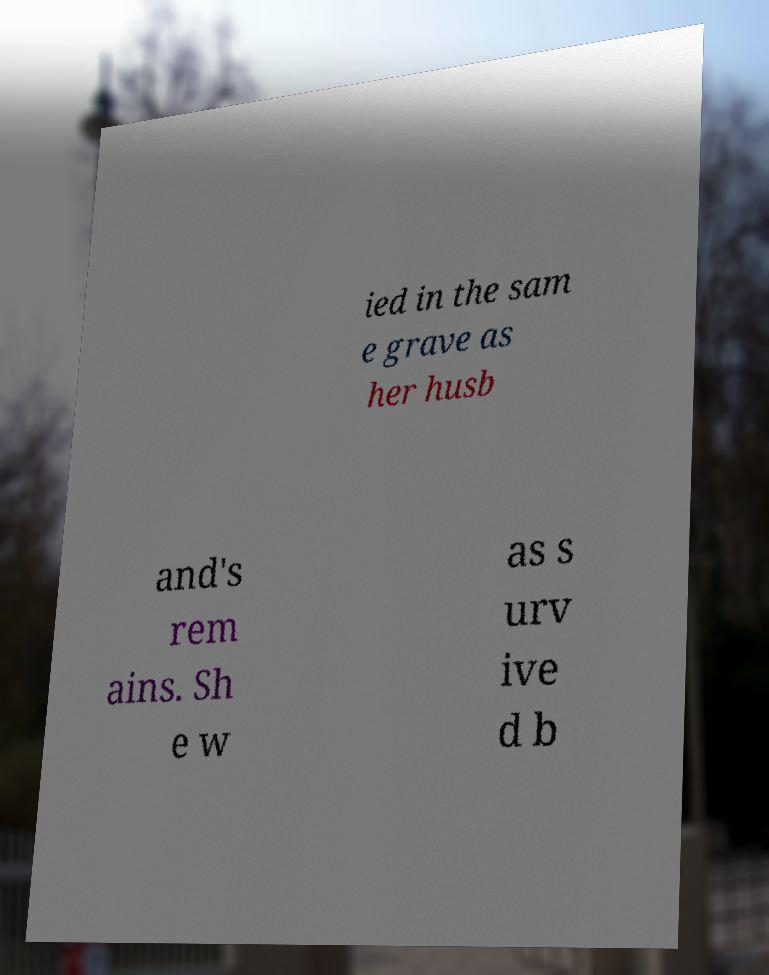For documentation purposes, I need the text within this image transcribed. Could you provide that? ied in the sam e grave as her husb and's rem ains. Sh e w as s urv ive d b 